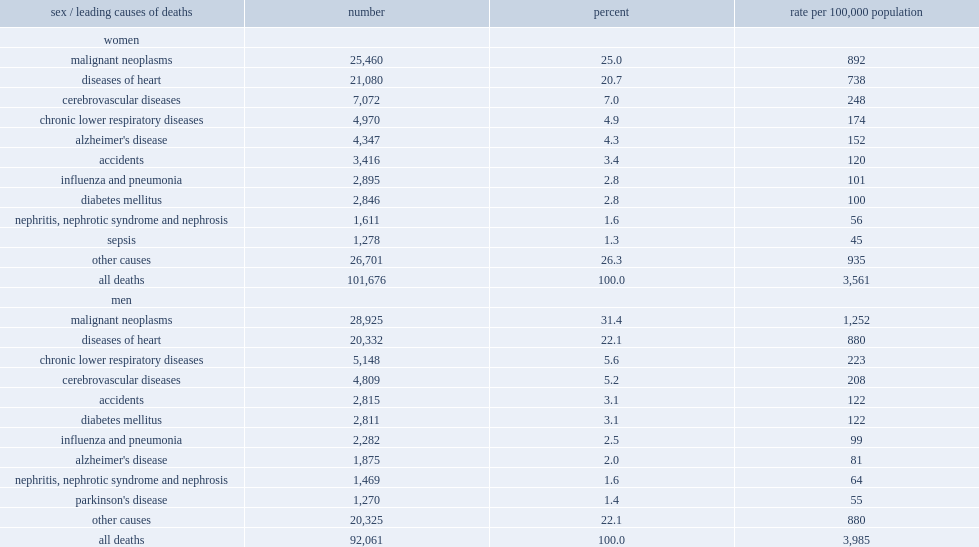What were the percentages of cause of death among women and men aged 65 and over were malignant neoplasms, or cancer. 25.0 31.4. Which was the second leading cause of death to senior women and men. Diseases of heart. Which was the the third leading cause of death for senior women and the fourth leading cause for senior men. Cerebrovascular diseases. Which were the he fourth most common cause of death among senior women. Chronic lower respiratory diseases. 